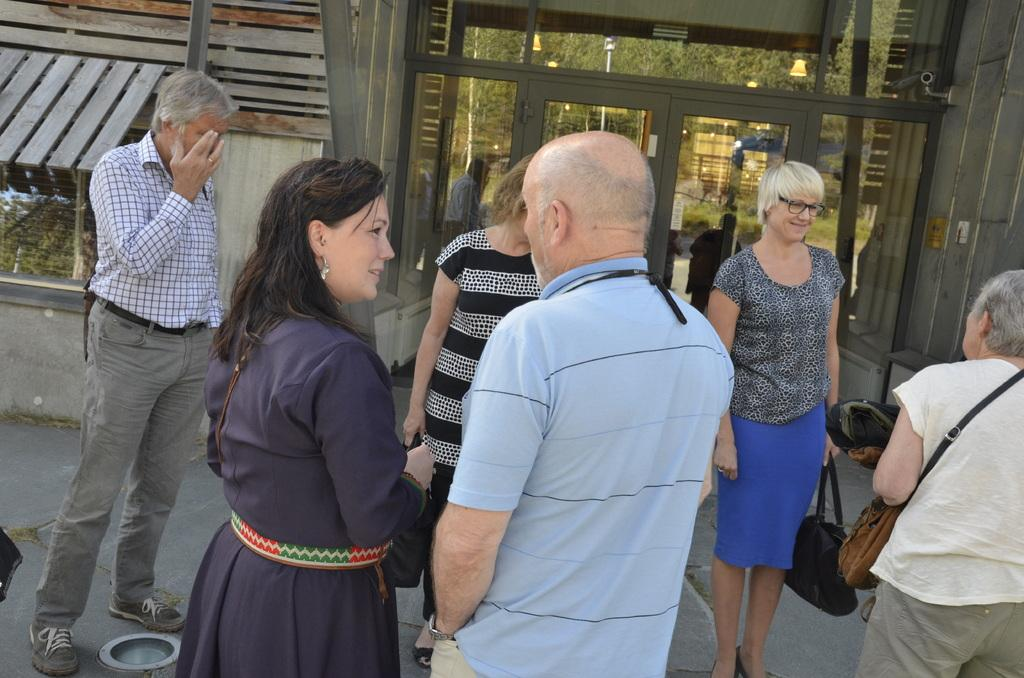How many persons are in the image? There are persons in the image, but the exact number is not specified. What are the persons doing in the image? The persons are on the floor, but their activity is not described. What can be seen in terms of clothing in the image? The persons are wearing different color dresses. What is visible in the background of the image? There is a building in the background of the image. What feature of the building is mentioned? The building has glass doors. What type of government is depicted in the image? There is no indication of a government or any political context in the image. What is the iron used for in the image? There is no iron present in the image. 